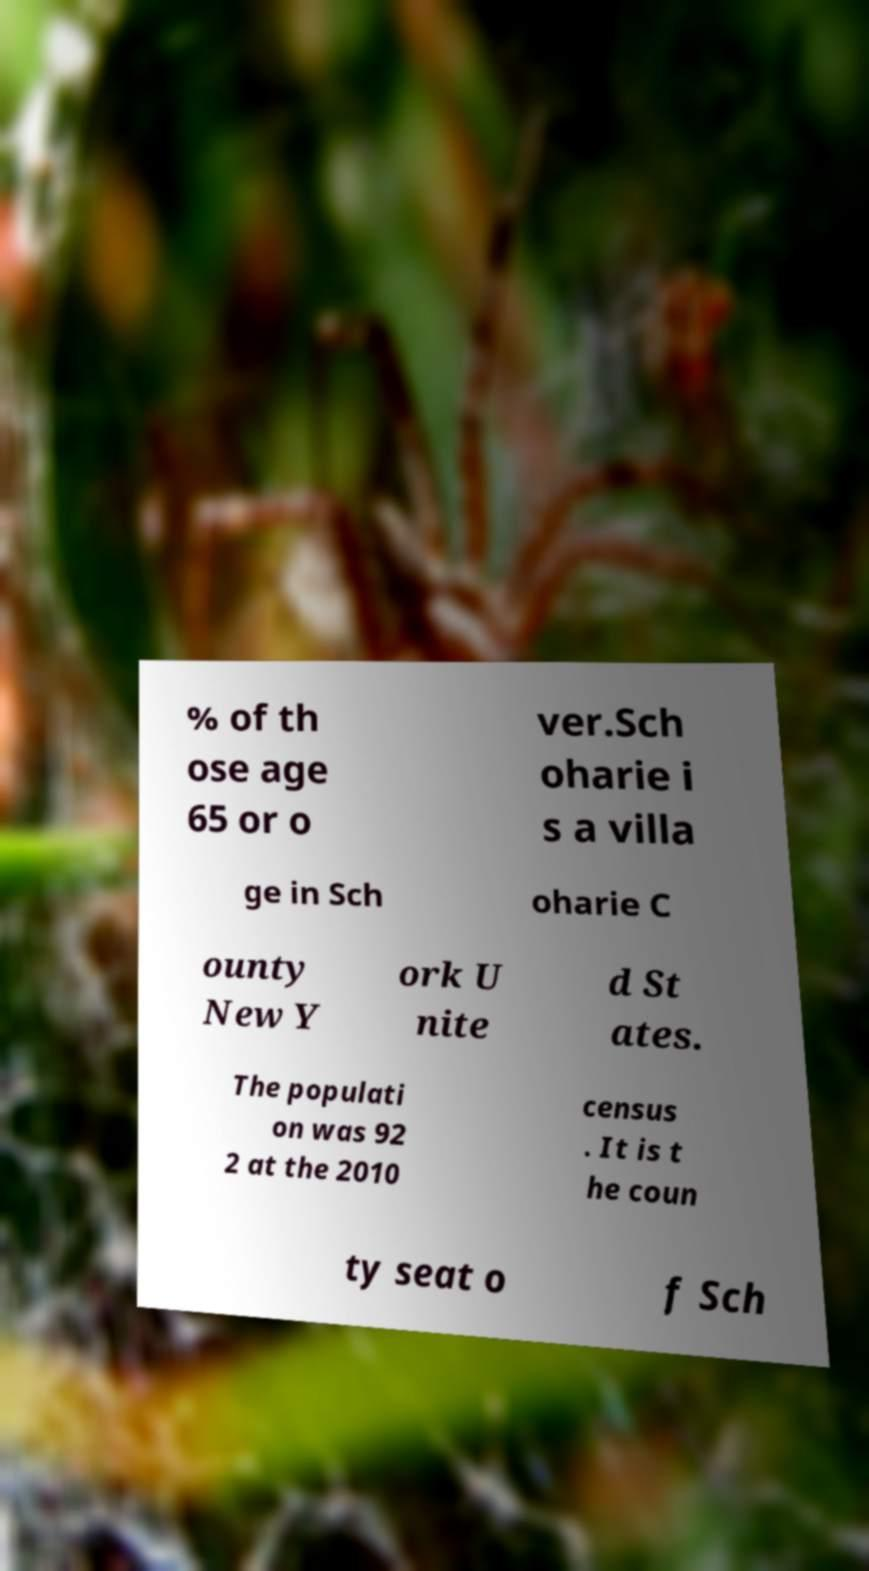Please identify and transcribe the text found in this image. % of th ose age 65 or o ver.Sch oharie i s a villa ge in Sch oharie C ounty New Y ork U nite d St ates. The populati on was 92 2 at the 2010 census . It is t he coun ty seat o f Sch 